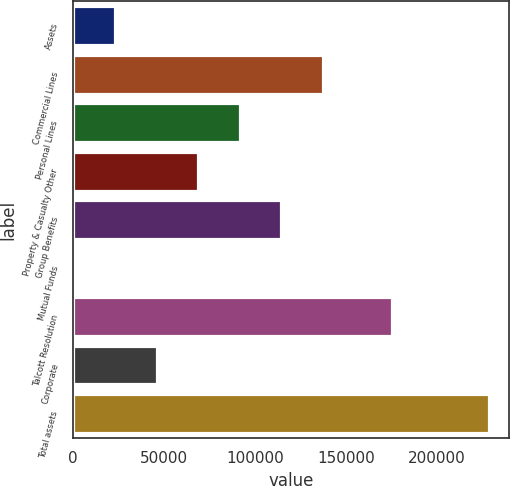Convert chart. <chart><loc_0><loc_0><loc_500><loc_500><bar_chart><fcel>Assets<fcel>Commercial Lines<fcel>Personal Lines<fcel>Property & Casualty Other<fcel>Group Benefits<fcel>Mutual Funds<fcel>Talcott Resolution<fcel>Corporate<fcel>Total assets<nl><fcel>23238.9<fcel>137188<fcel>91608.6<fcel>68818.7<fcel>114398<fcel>449<fcel>175319<fcel>46028.8<fcel>228348<nl></chart> 